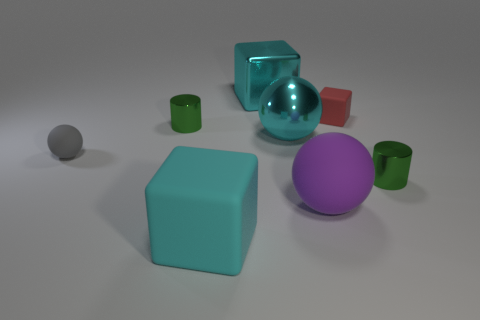Add 1 red rubber spheres. How many objects exist? 9 Subtract all cubes. How many objects are left? 5 Subtract 0 brown cubes. How many objects are left? 8 Subtract all cyan spheres. Subtract all small red cubes. How many objects are left? 6 Add 1 tiny gray rubber things. How many tiny gray rubber things are left? 2 Add 7 large brown matte objects. How many large brown matte objects exist? 7 